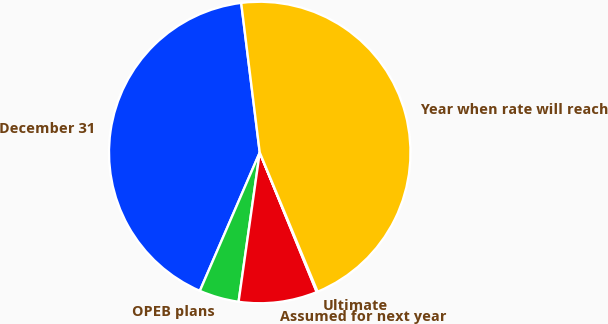<chart> <loc_0><loc_0><loc_500><loc_500><pie_chart><fcel>December 31<fcel>OPEB plans<fcel>Assumed for next year<fcel>Ultimate<fcel>Year when rate will reach<nl><fcel>41.53%<fcel>4.26%<fcel>8.41%<fcel>0.1%<fcel>45.69%<nl></chart> 